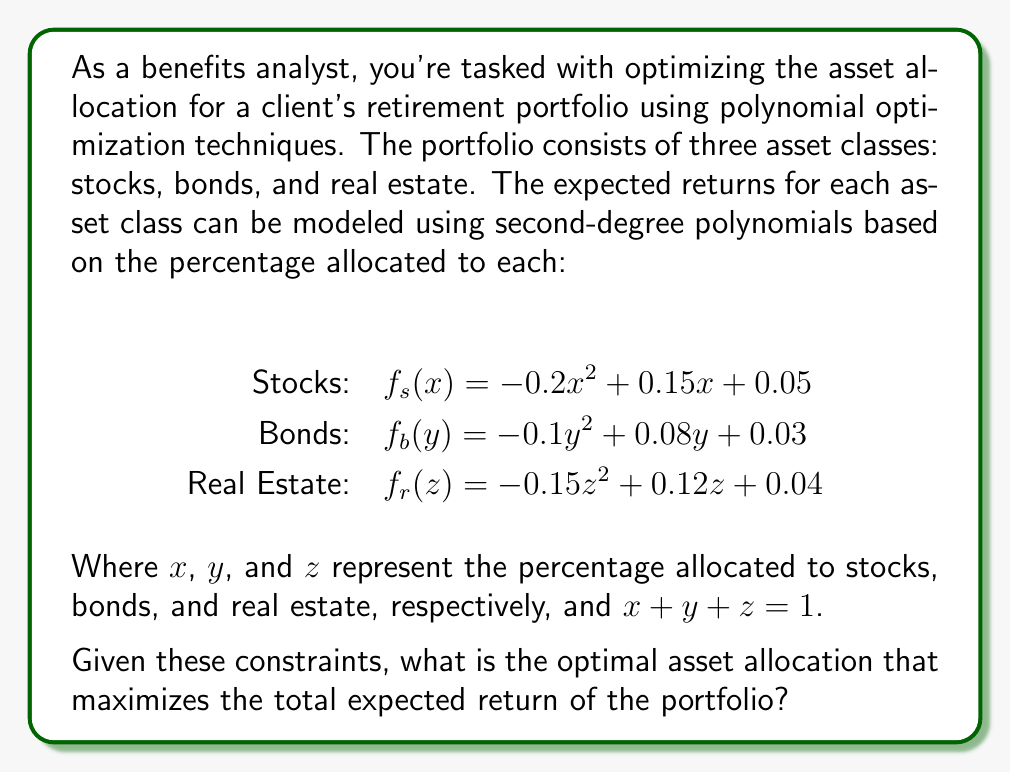Can you solve this math problem? To solve this optimization problem, we need to follow these steps:

1) First, we need to create an objective function that represents the total expected return of the portfolio:

   $f(x,y,z) = f_s(x) + f_b(y) + f_r(z)$
   
   $f(x,y,z) = (-0.2x^2 + 0.15x + 0.05) + (-0.1y^2 + 0.08y + 0.03) + (-0.15z^2 + 0.12z + 0.04)$

2) We have the constraint that $x + y + z = 1$. We can use this to eliminate one variable. Let's eliminate $z$:

   $z = 1 - x - y$

3) Substituting this into our objective function:

   $f(x,y) = (-0.2x^2 + 0.15x + 0.05) + (-0.1y^2 + 0.08y + 0.03) + (-0.15(1-x-y)^2 + 0.12(1-x-y) + 0.04)$

4) Expanding this:

   $f(x,y) = -0.2x^2 + 0.15x + 0.05 - 0.1y^2 + 0.08y + 0.03 - 0.15(1-2x+x^2-2y+2xy+y^2) + 0.12 - 0.12x - 0.12y + 0.04$

5) Simplifying:

   $f(x,y) = -0.05x^2 - 0.25y^2 + 0.3xy + 0.27x + 0.2y + 0.07$

6) To find the maximum of this function, we need to find where its partial derivatives are zero:

   $\frac{\partial f}{\partial x} = -0.1x + 0.3y + 0.27 = 0$
   $\frac{\partial f}{\partial y} = -0.5y + 0.3x + 0.2 = 0$

7) Solving this system of equations:

   From the second equation: $x = \frac{5y-2}{3}$
   
   Substituting into the first equation:
   
   $-0.1(\frac{5y-2}{3}) + 0.3y + 0.27 = 0$
   
   $-0.5y + 0.2 + 0.9y + 0.81 = 0$
   
   $0.4y = -1.01$
   
   $y = -2.525$

   Substituting back:
   
   $x = \frac{5(-2.525)-2}{3} = -4.875$

8) However, these values are outside our constraint of $0 \leq x,y,z \leq 1$. This means the maximum must occur on the boundary of our constraint region.

9) Given that $x + y + z = 1$ and all variables are non-negative, we can represent this as a triangle in the x-y plane. The maximum will occur at one of the vertices of this triangle.

10) The three vertices are (1,0), (0,1), and (0,0) in x-y coordinates, corresponding to (1,0,0), (0,1,0), and (0,0,1) in x-y-z coordinates.

11) Evaluating our original function at these points:

    $f(1,0,0) = -0.2(1)^2 + 0.15(1) + 0.05 = 0$
    $f(0,1,0) = -0.1(1)^2 + 0.08(1) + 0.03 = 0.01$
    $f(0,0,1) = -0.15(1)^2 + 0.12(1) + 0.04 = 0.01$

Therefore, the maximum occurs at either (0,1,0) or (0,0,1), corresponding to allocating 100% to bonds or 100% to real estate.
Answer: The optimal asset allocation that maximizes the total expected return is either 100% bonds $(0,1,0)$ or 100% real estate $(0,0,1)$, both yielding an expected return of 0.01 or 1%. 